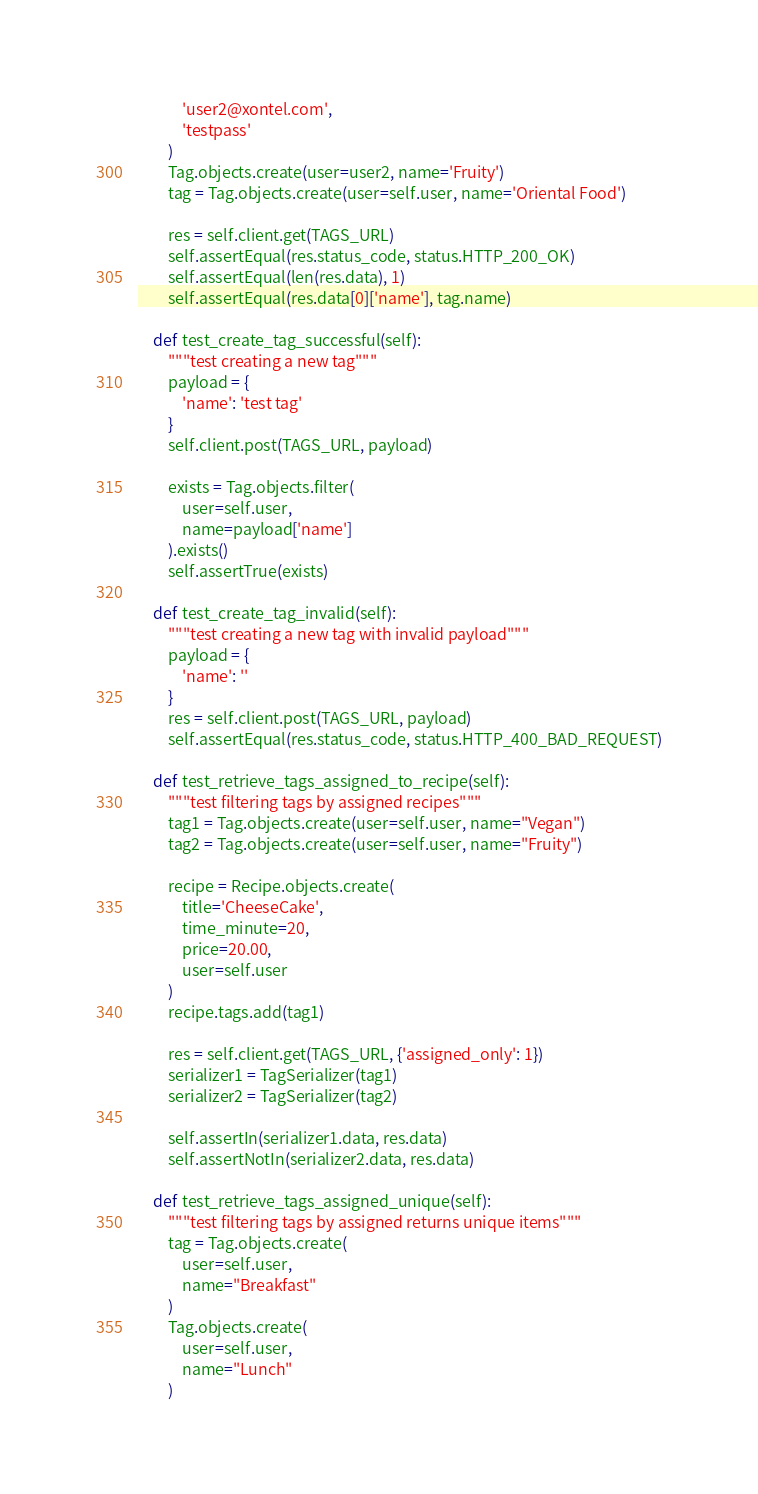<code> <loc_0><loc_0><loc_500><loc_500><_Python_>            'user2@xontel.com',
            'testpass'
        )
        Tag.objects.create(user=user2, name='Fruity')
        tag = Tag.objects.create(user=self.user, name='Oriental Food')

        res = self.client.get(TAGS_URL)
        self.assertEqual(res.status_code, status.HTTP_200_OK)
        self.assertEqual(len(res.data), 1)
        self.assertEqual(res.data[0]['name'], tag.name)

    def test_create_tag_successful(self):
        """test creating a new tag"""
        payload = {
            'name': 'test tag'
        }
        self.client.post(TAGS_URL, payload)

        exists = Tag.objects.filter(
            user=self.user,
            name=payload['name']
        ).exists()
        self.assertTrue(exists)

    def test_create_tag_invalid(self):
        """test creating a new tag with invalid payload"""
        payload = {
            'name': ''
        }
        res = self.client.post(TAGS_URL, payload)
        self.assertEqual(res.status_code, status.HTTP_400_BAD_REQUEST)

    def test_retrieve_tags_assigned_to_recipe(self):
        """test filtering tags by assigned recipes"""
        tag1 = Tag.objects.create(user=self.user, name="Vegan")
        tag2 = Tag.objects.create(user=self.user, name="Fruity")

        recipe = Recipe.objects.create(
            title='CheeseCake',
            time_minute=20,
            price=20.00,
            user=self.user
        )
        recipe.tags.add(tag1)

        res = self.client.get(TAGS_URL, {'assigned_only': 1})
        serializer1 = TagSerializer(tag1)
        serializer2 = TagSerializer(tag2)

        self.assertIn(serializer1.data, res.data)
        self.assertNotIn(serializer2.data, res.data)

    def test_retrieve_tags_assigned_unique(self):
        """test filtering tags by assigned returns unique items"""
        tag = Tag.objects.create(
            user=self.user,
            name="Breakfast"
        )
        Tag.objects.create(
            user=self.user,
            name="Lunch"
        )</code> 